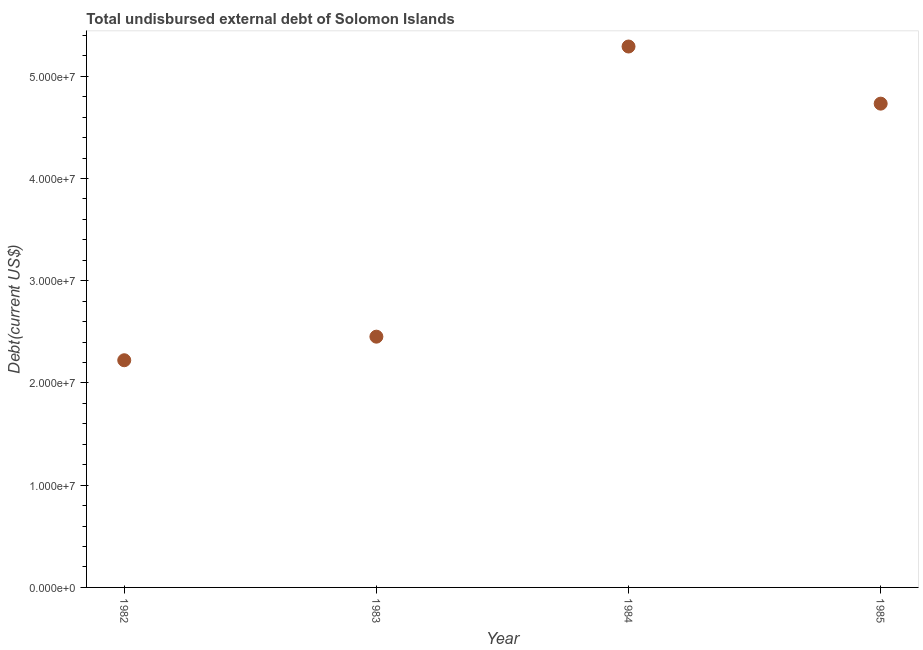What is the total debt in 1982?
Make the answer very short. 2.22e+07. Across all years, what is the maximum total debt?
Ensure brevity in your answer.  5.29e+07. Across all years, what is the minimum total debt?
Offer a very short reply. 2.22e+07. In which year was the total debt minimum?
Offer a very short reply. 1982. What is the sum of the total debt?
Your answer should be very brief. 1.47e+08. What is the difference between the total debt in 1982 and 1984?
Make the answer very short. -3.07e+07. What is the average total debt per year?
Your response must be concise. 3.68e+07. What is the median total debt?
Your response must be concise. 3.59e+07. Do a majority of the years between 1983 and 1984 (inclusive) have total debt greater than 42000000 US$?
Give a very brief answer. No. What is the ratio of the total debt in 1983 to that in 1985?
Make the answer very short. 0.52. What is the difference between the highest and the second highest total debt?
Your answer should be very brief. 5.59e+06. What is the difference between the highest and the lowest total debt?
Your answer should be compact. 3.07e+07. In how many years, is the total debt greater than the average total debt taken over all years?
Offer a very short reply. 2. How many dotlines are there?
Ensure brevity in your answer.  1. How many years are there in the graph?
Give a very brief answer. 4. What is the difference between two consecutive major ticks on the Y-axis?
Make the answer very short. 1.00e+07. Does the graph contain grids?
Offer a terse response. No. What is the title of the graph?
Make the answer very short. Total undisbursed external debt of Solomon Islands. What is the label or title of the X-axis?
Offer a terse response. Year. What is the label or title of the Y-axis?
Offer a very short reply. Debt(current US$). What is the Debt(current US$) in 1982?
Provide a succinct answer. 2.22e+07. What is the Debt(current US$) in 1983?
Keep it short and to the point. 2.45e+07. What is the Debt(current US$) in 1984?
Offer a terse response. 5.29e+07. What is the Debt(current US$) in 1985?
Provide a short and direct response. 4.73e+07. What is the difference between the Debt(current US$) in 1982 and 1983?
Ensure brevity in your answer.  -2.31e+06. What is the difference between the Debt(current US$) in 1982 and 1984?
Give a very brief answer. -3.07e+07. What is the difference between the Debt(current US$) in 1982 and 1985?
Your response must be concise. -2.51e+07. What is the difference between the Debt(current US$) in 1983 and 1984?
Give a very brief answer. -2.84e+07. What is the difference between the Debt(current US$) in 1983 and 1985?
Offer a terse response. -2.28e+07. What is the difference between the Debt(current US$) in 1984 and 1985?
Ensure brevity in your answer.  5.59e+06. What is the ratio of the Debt(current US$) in 1982 to that in 1983?
Make the answer very short. 0.91. What is the ratio of the Debt(current US$) in 1982 to that in 1984?
Your answer should be compact. 0.42. What is the ratio of the Debt(current US$) in 1982 to that in 1985?
Provide a succinct answer. 0.47. What is the ratio of the Debt(current US$) in 1983 to that in 1984?
Make the answer very short. 0.46. What is the ratio of the Debt(current US$) in 1983 to that in 1985?
Your answer should be very brief. 0.52. What is the ratio of the Debt(current US$) in 1984 to that in 1985?
Keep it short and to the point. 1.12. 